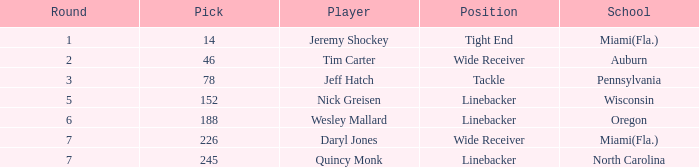From what school was the player drafted in round 3? Pennsylvania. Could you help me parse every detail presented in this table? {'header': ['Round', 'Pick', 'Player', 'Position', 'School'], 'rows': [['1', '14', 'Jeremy Shockey', 'Tight End', 'Miami(Fla.)'], ['2', '46', 'Tim Carter', 'Wide Receiver', 'Auburn'], ['3', '78', 'Jeff Hatch', 'Tackle', 'Pennsylvania'], ['5', '152', 'Nick Greisen', 'Linebacker', 'Wisconsin'], ['6', '188', 'Wesley Mallard', 'Linebacker', 'Oregon'], ['7', '226', 'Daryl Jones', 'Wide Receiver', 'Miami(Fla.)'], ['7', '245', 'Quincy Monk', 'Linebacker', 'North Carolina']]} 